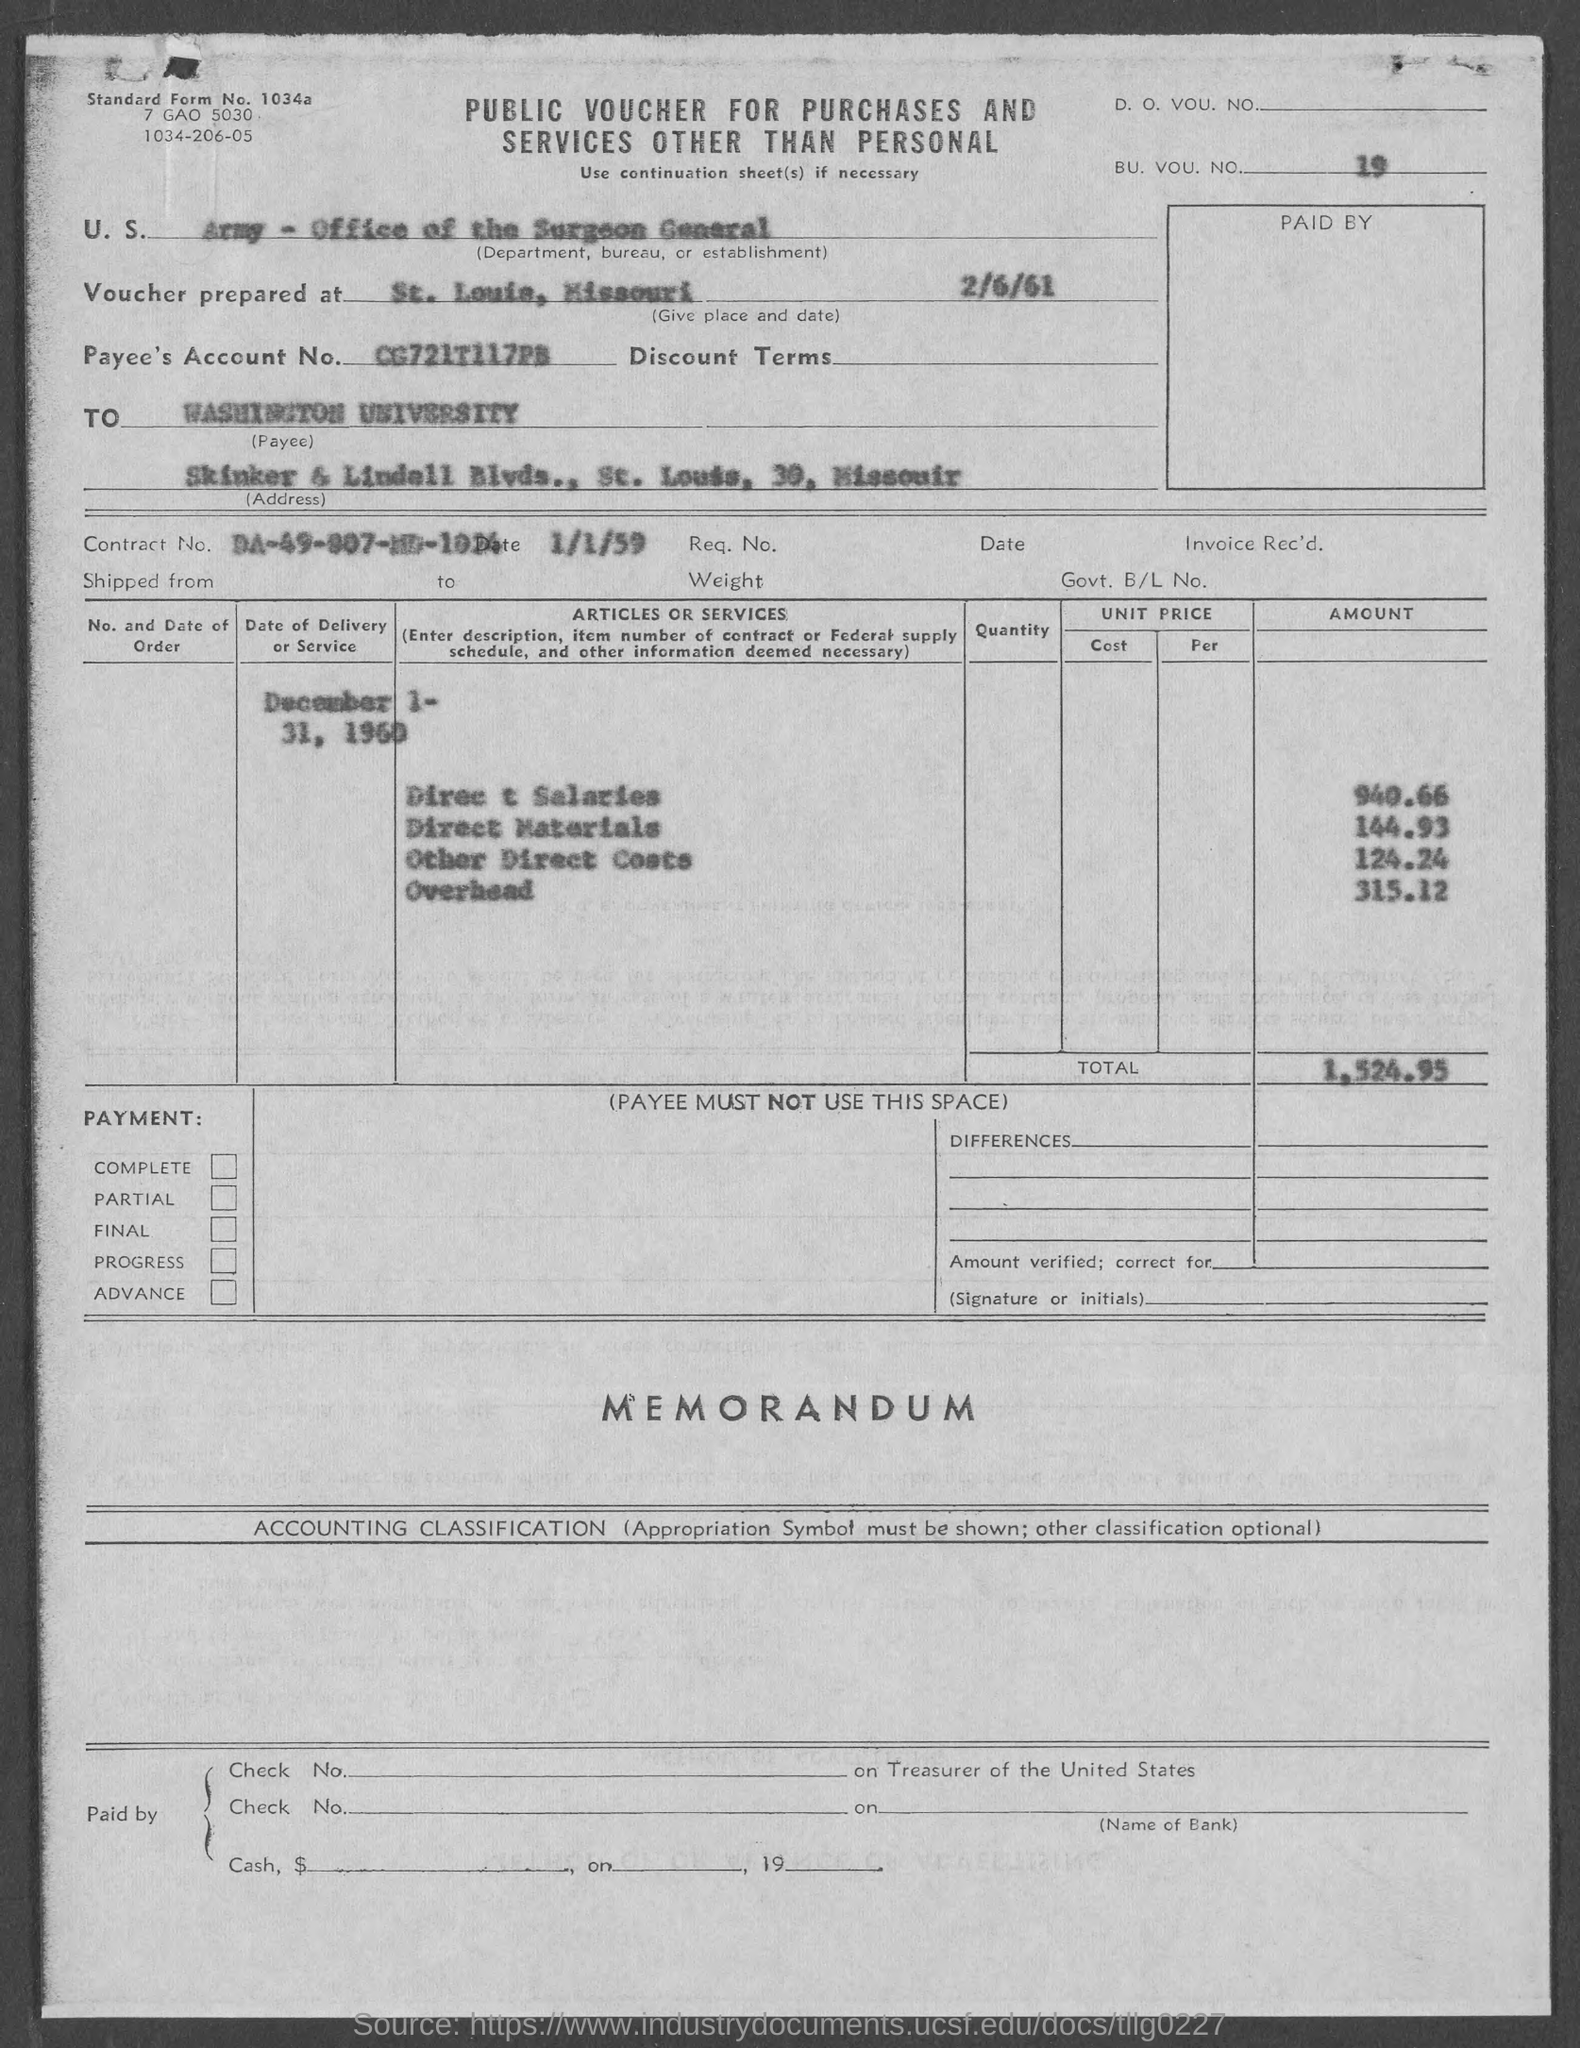Highlight a few significant elements in this photo. The voucher was prepared in St. Louis, Missouri. The payee's account number is CG721T117PB.. The payee is Washington University. What is the BU. VOU. NO? 19.." is a question that seeks information about a specific date. 